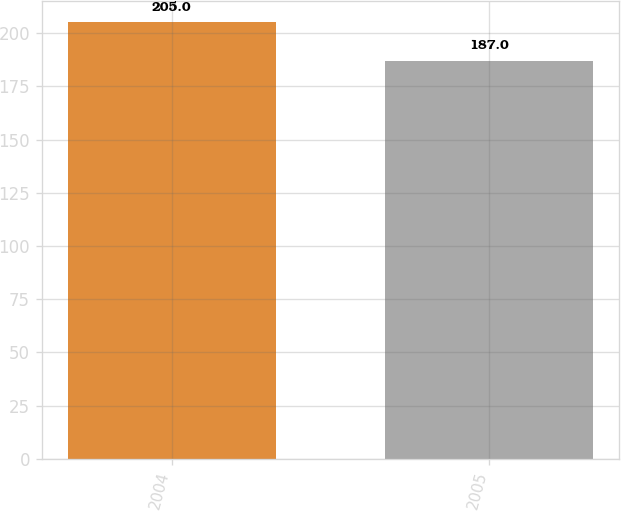Convert chart to OTSL. <chart><loc_0><loc_0><loc_500><loc_500><bar_chart><fcel>2004<fcel>2005<nl><fcel>205<fcel>187<nl></chart> 